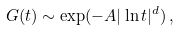Convert formula to latex. <formula><loc_0><loc_0><loc_500><loc_500>G ( t ) \sim \exp ( - A | \ln t | ^ { d } ) \, ,</formula> 